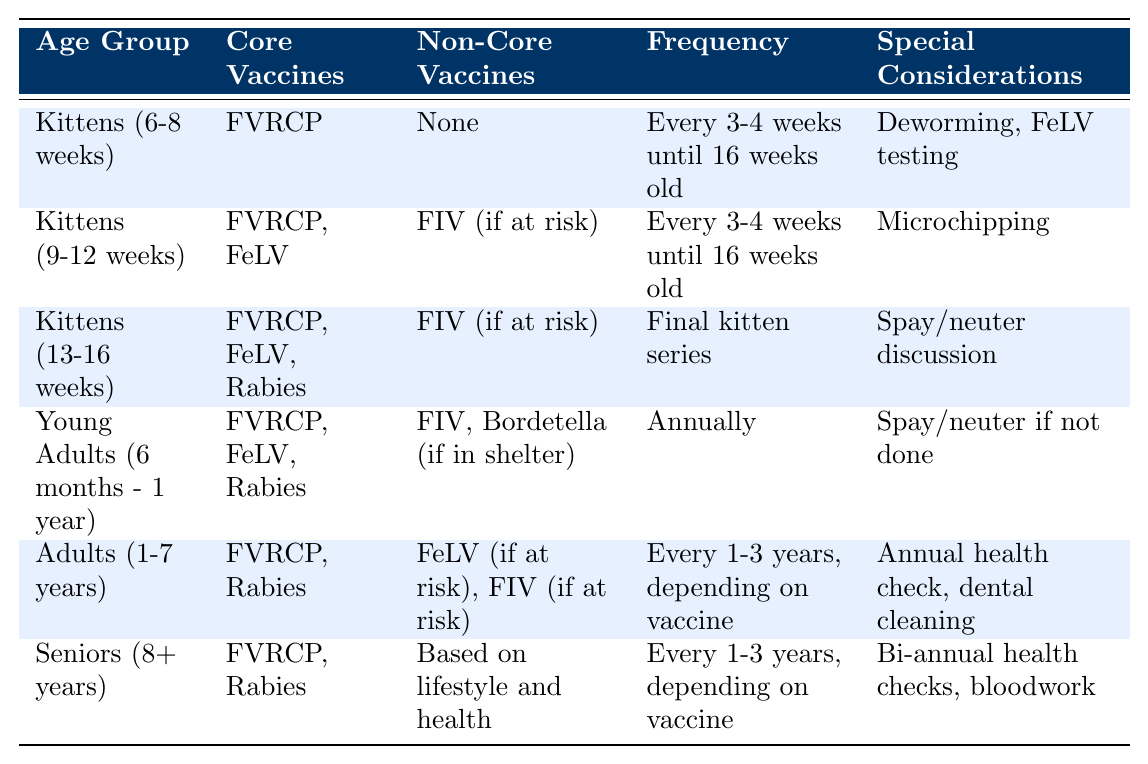What are the core vaccines for kittens aged 6-8 weeks? According to the table, the core vaccine for kittens aged 6-8 weeks is FVRCP.
Answer: FVRCP How often should kittens aged 9-12 weeks be vaccinated? The table states that kittens aged 9-12 weeks should be vaccinated every 3-4 weeks until they are 16 weeks old.
Answer: Every 3-4 weeks until 16 weeks old Do young adults require the same frequency of vaccination as seniors? The table indicates that young adults are vaccinated annually, while seniors are vaccinated every 1-3 years, which shows they do not share the same frequency of vaccination.
Answer: No Which age group has both FVRCP and FeLV as core vaccines? Looking at the table, both young adults (6 months - 1 year) and kittens (9-12 weeks) have FVRCP and FeLV listed as core vaccines.
Answer: Kittens (9-12 weeks) and Young Adults (6 months - 1 year) What special considerations are noted for seniors? The table lists bi-annual health checks and bloodwork as the special considerations for seniors.
Answer: Bi-annual health checks, bloodwork Which age group receives the final kitten series of vaccines? The table specifies that kittens aged 13-16 weeks receive the final kitten series of vaccines, which includes core vaccines like FVRCP, FeLV, and Rabies.
Answer: Kittens (13-16 weeks) For adult cats, how long is the frequency of vaccinations dependent on the vaccine? The table mentions that adult cats (1-7 years) have vaccinations every 1-3 years, depending on the vaccine used.
Answer: Every 1-3 years, depending on vaccine What non-core vaccine is recommended for kittens aged 9-12 weeks if at risk? According to the table, FIV is the non-core vaccine recommended for kittens aged 9-12 weeks if they are at risk.
Answer: FIV (if at risk) Identify the frequency of vaccination for kittens aged 6-8 weeks and 9-12 weeks. The frequency for both of these age groups is the same: every 3-4 weeks until 16 weeks old, as stated in the table.
Answer: Every 3-4 weeks until 16 weeks old Are there any core vaccines listed for senior cats? Yes, the table indicates that seniors (8+ years) have FVRCP and Rabies as core vaccines.
Answer: Yes What is the primary focus during the special considerations for kittens aged 13-16 weeks? The table highlights that the primary focus for kittens aged 13-16 weeks includes a spay/neuter discussion as part of their special considerations.
Answer: Spay/neuter discussion 